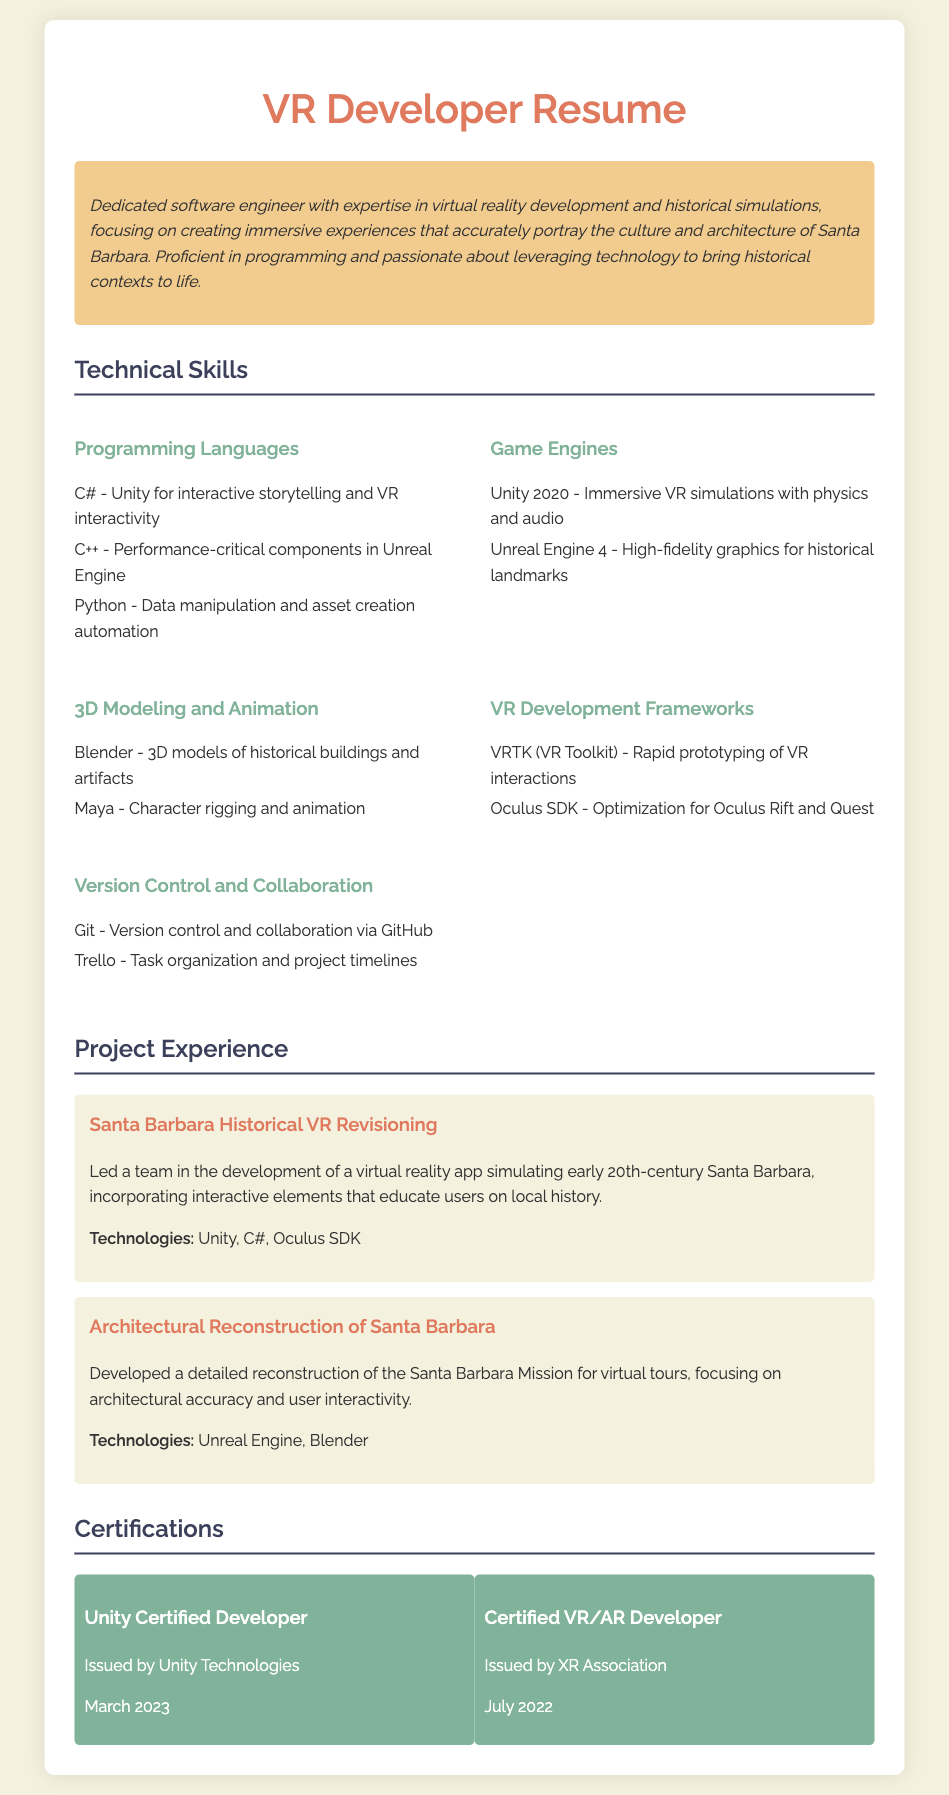what programming language is used for Unity? The document states that C# is used for Unity, specifically for interactive storytelling and VR interactivity.
Answer: C# what game engine is utilized for high-fidelity graphics? According to the document, Unreal Engine 4 is utilized for high-fidelity graphics for historical landmarks.
Answer: Unreal Engine 4 how many certifications does the developer have? The document lists two certifications: Unity Certified Developer and Certified VR/AR Developer.
Answer: 2 which tool is mentioned for task organization? Trello is mentioned in the document as a tool for task organization and project timelines.
Answer: Trello what year did the Unity Certified Developer certification get issued? The document states that the Unity Certified Developer certification was issued in March 2023.
Answer: March 2023 what is the focus of the Santa Barbara Historical VR Revisioning project? The project focuses on simulating early 20th-century Santa Barbara and educating users on local history.
Answer: educating users on local history which 3D modeling software is used for historical buildings? Blender is identified in the document as the software used for creating 3D models of historical buildings and artifacts.
Answer: Blender what framework is used for rapid prototyping of VR interactions? VRTK (VR Toolkit) is the framework mentioned for rapid prototyping of VR interactions.
Answer: VRTK which VR SDK is optimized for Oculus Rift? The document states that the Oculus SDK is optimized for Oculus Rift and Quest.
Answer: Oculus SDK 